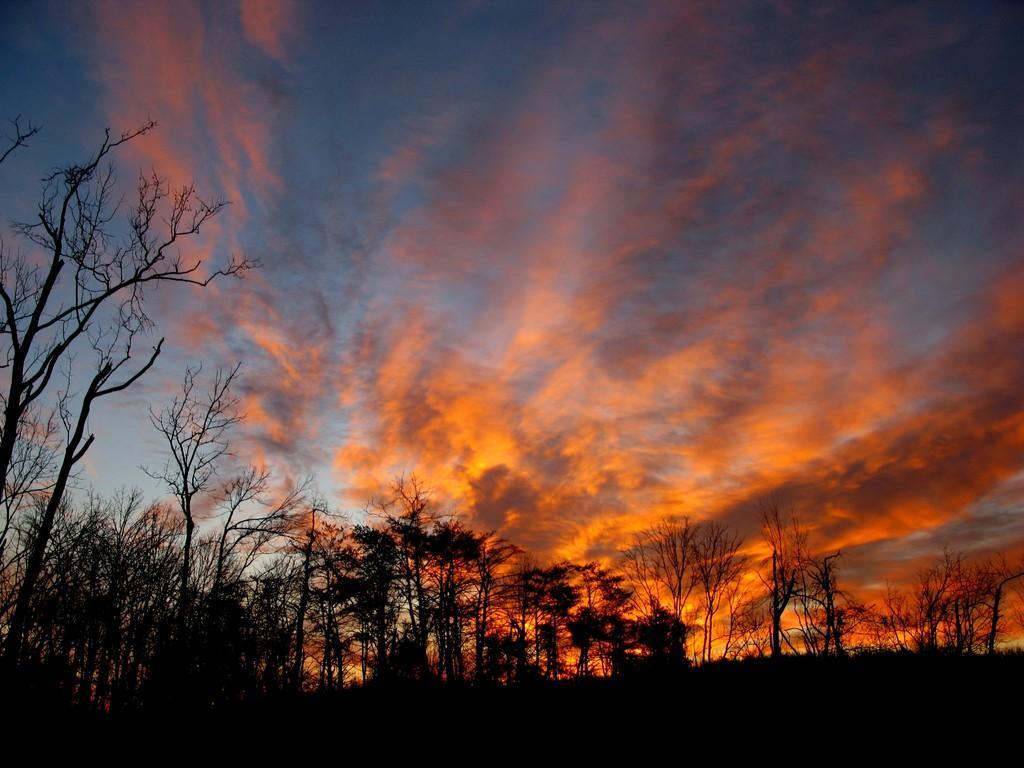Please provide a concise description of this image. In this image we can see there are some trees and in the background, we can see the sky with clouds. 